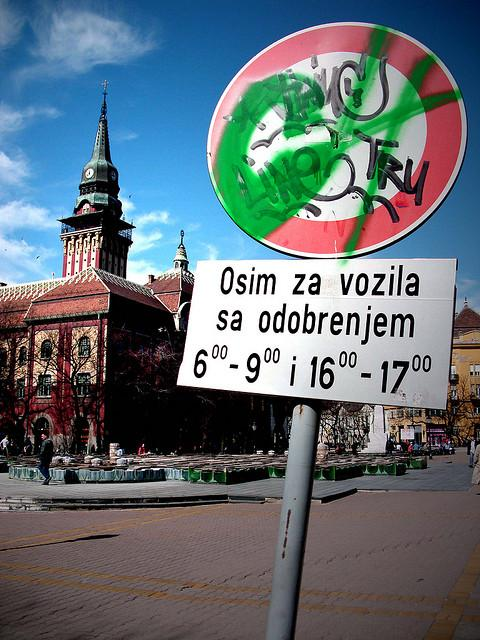What are the green markings an example of? graffiti 